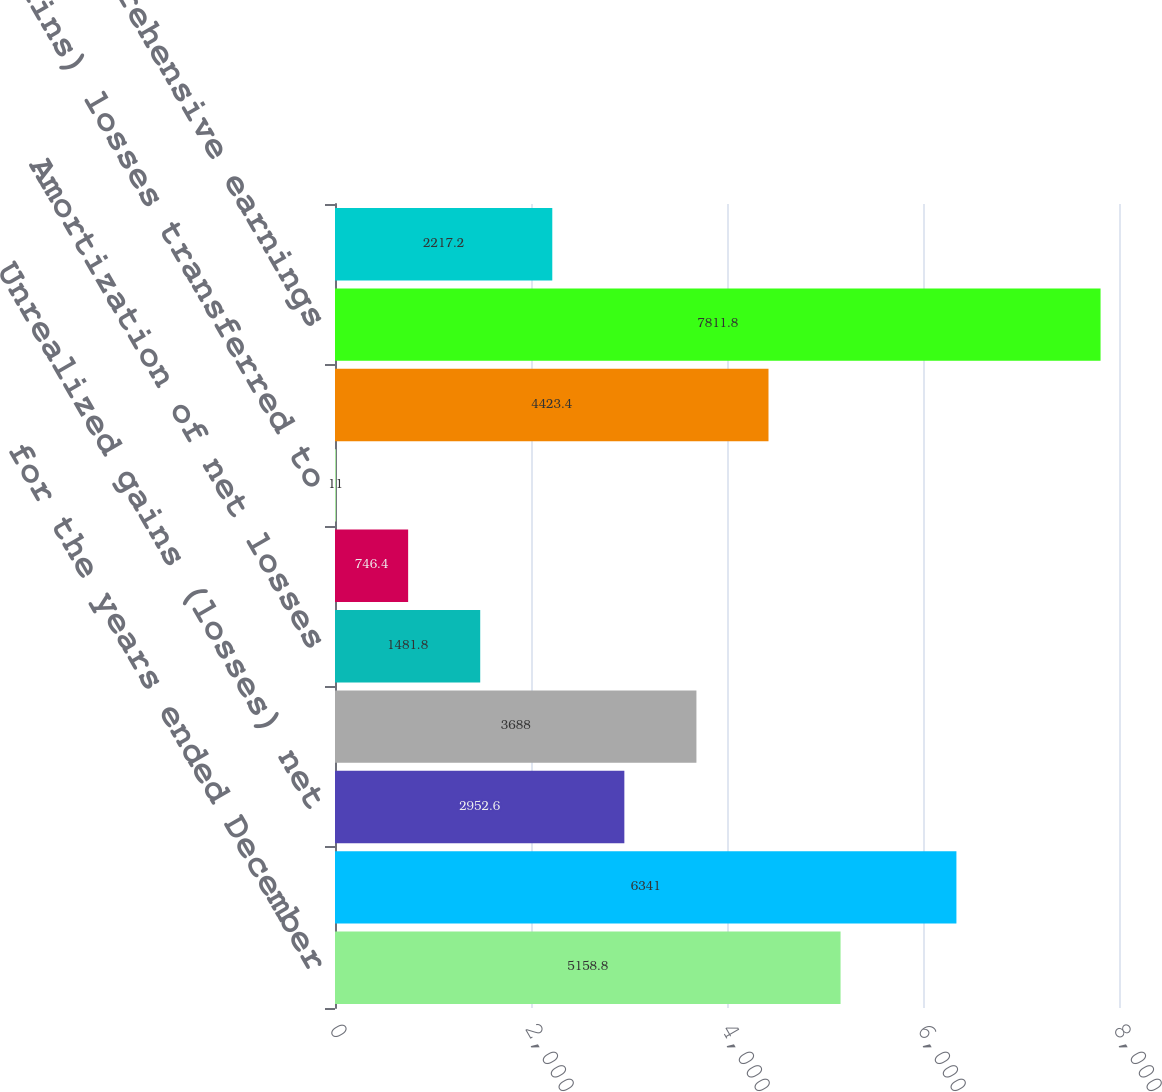Convert chart to OTSL. <chart><loc_0><loc_0><loc_500><loc_500><bar_chart><fcel>for the years ended December<fcel>Net earnings<fcel>Unrealized gains (losses) net<fcel>Net gains (losses) and prior<fcel>Amortization of net losses<fcel>Gains (losses) recognized net<fcel>(Gains) losses transferred to<fcel>Total other comprehensive<fcel>Total comprehensive earnings<fcel>Noncontrolling interests<nl><fcel>5158.8<fcel>6341<fcel>2952.6<fcel>3688<fcel>1481.8<fcel>746.4<fcel>11<fcel>4423.4<fcel>7811.8<fcel>2217.2<nl></chart> 